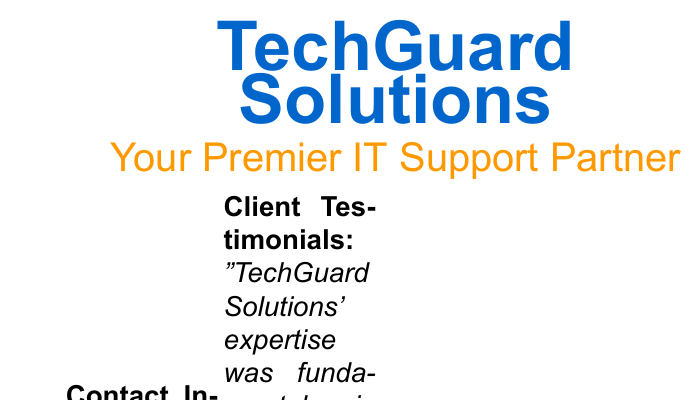What is the company name? The company name is prominently displayed at the top of the document.
Answer: TechGuard Solutions Who is the contact person for support? The document does not specify an individual contact person, only a general support email.
Answer: support@techguard.com What is one service mentioned in the testimonials? The testimonials highlight a specific service related to IT support.
Answer: cloud migration How many testimonials are provided? The number of testimonials can be counted in the designated section of the document.
Answer: 2 What city is TechGuard Solutions located in? The location of the company is mentioned in the contact information section.
Answer: Silicon Valley Who provided a testimonial about IT downtime? The document mentions a specific client in one of the testimonials about reduced IT downtime.
Answer: Emily J., Green Meadow Consulting What color is used for the company name? The specific color for the company name can be inferred from the design choices made in the document.
Answer: primarycolor What type of support does TechGuard Solutions offer? The overall pitch of the company can be gleaned from the subtitle section of the document.
Answer: IT Support Partner 